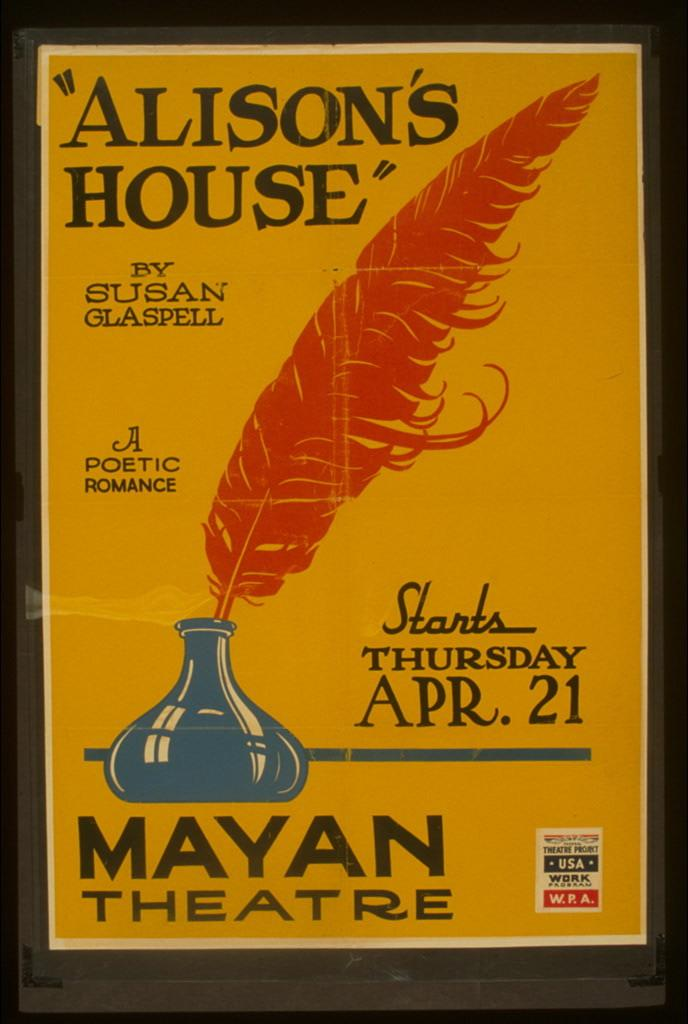<image>
Create a compact narrative representing the image presented. A signboard for a play starting April 21st by Susan Glaspell. 